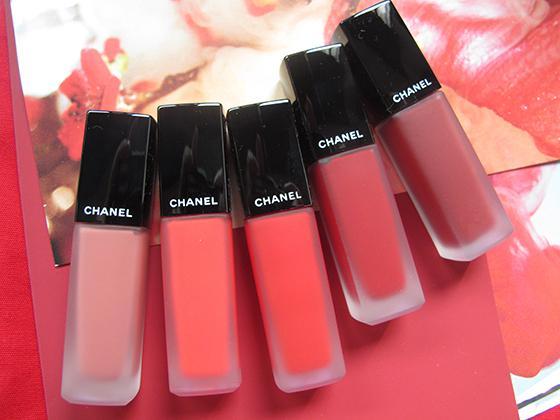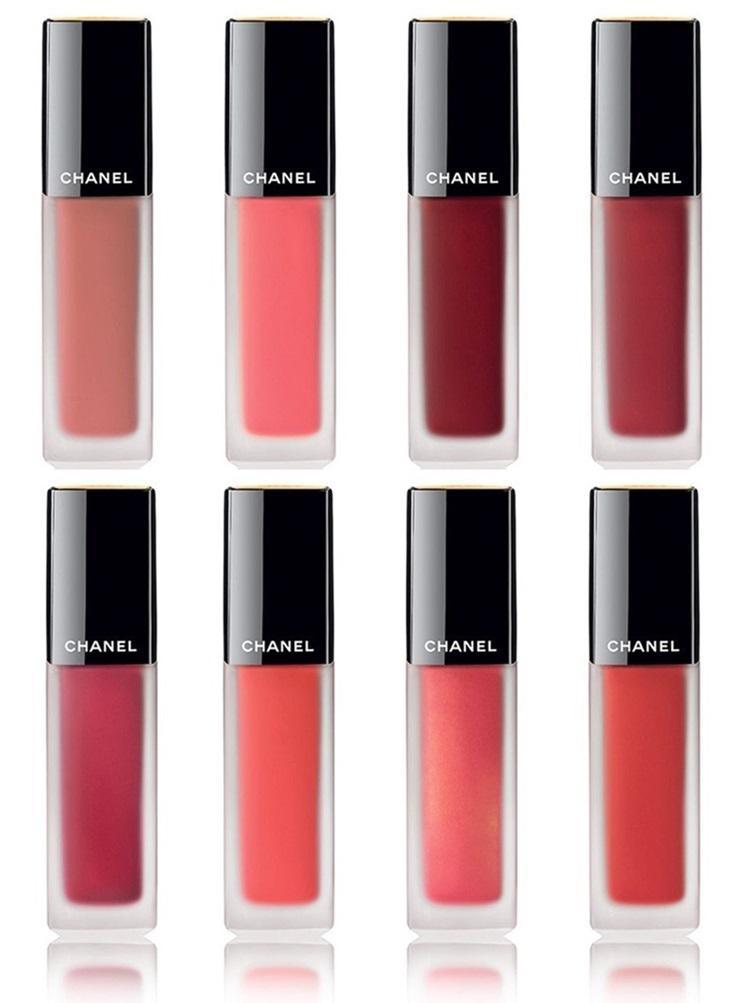The first image is the image on the left, the second image is the image on the right. For the images shown, is this caption "lipsticks are shown with the lids off" true? Answer yes or no. No. The first image is the image on the left, the second image is the image on the right. For the images displayed, is the sentence "An image shows exactly one lip makeup item, displayed with its cap removed." factually correct? Answer yes or no. No. 